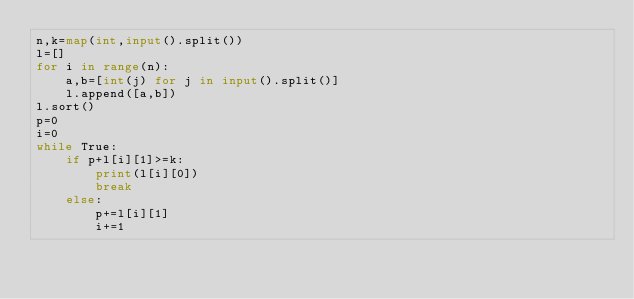<code> <loc_0><loc_0><loc_500><loc_500><_Python_>n,k=map(int,input().split())
l=[]
for i in range(n):
    a,b=[int(j) for j in input().split()]
    l.append([a,b])
l.sort()
p=0
i=0
while True:
    if p+l[i][1]>=k:
        print(l[i][0])
        break
    else:
        p+=l[i][1]
        i+=1

</code> 